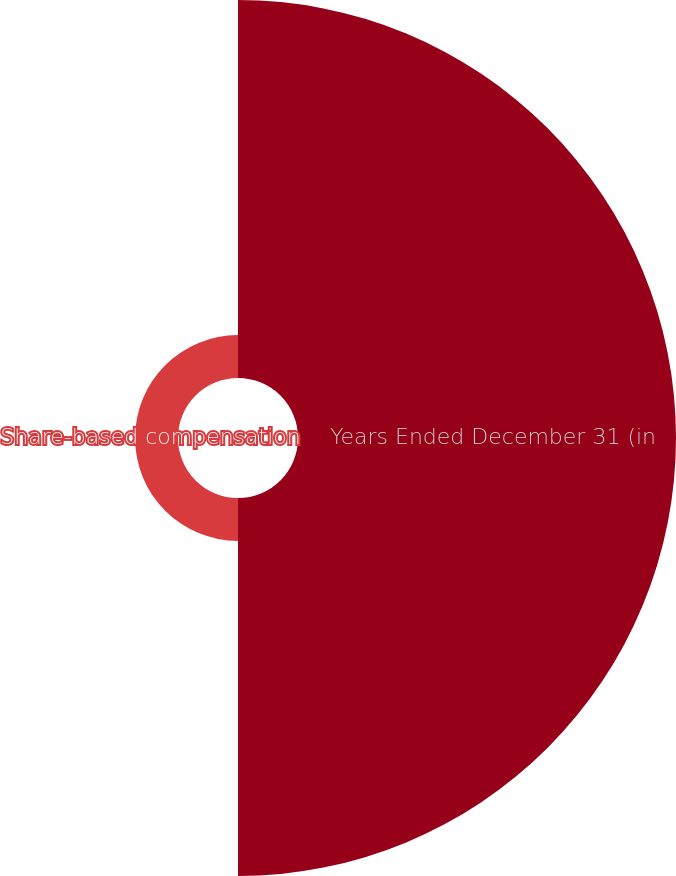Convert chart. <chart><loc_0><loc_0><loc_500><loc_500><pie_chart><fcel>Years Ended December 31 (in<fcel>Share-based compensation<nl><fcel>89.8%<fcel>10.2%<nl></chart> 